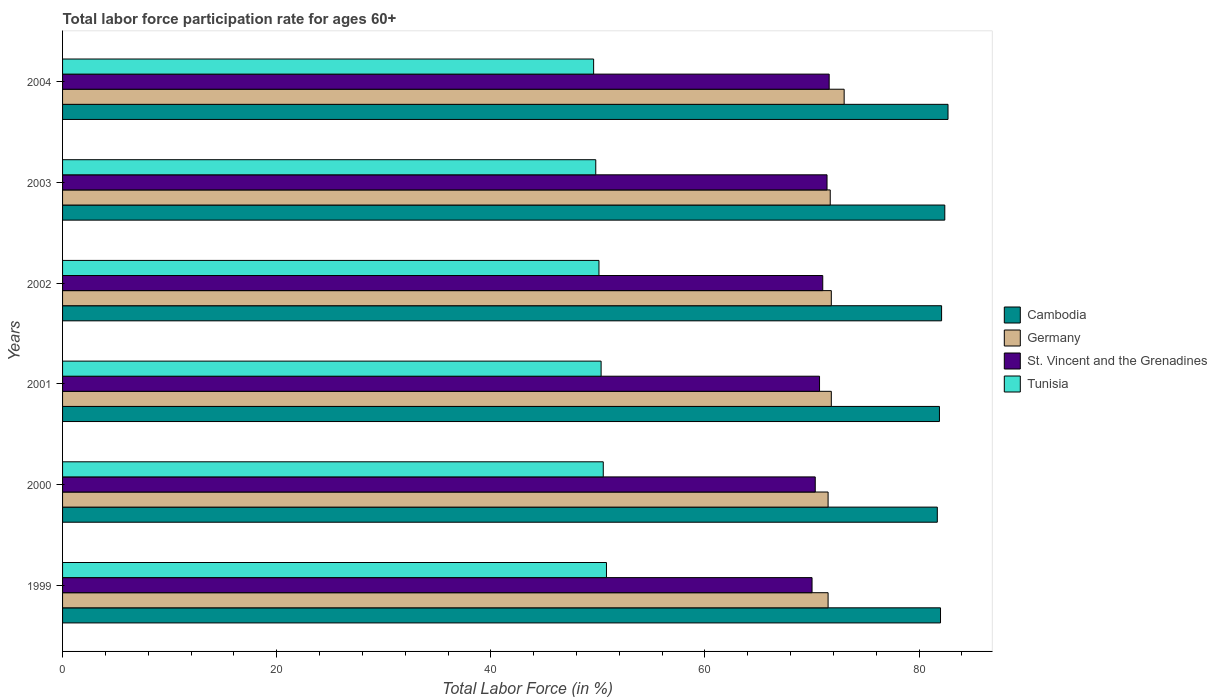How many different coloured bars are there?
Provide a short and direct response. 4. How many groups of bars are there?
Provide a succinct answer. 6. Are the number of bars on each tick of the Y-axis equal?
Ensure brevity in your answer.  Yes. How many bars are there on the 4th tick from the bottom?
Your answer should be very brief. 4. Across all years, what is the maximum labor force participation rate in Tunisia?
Your response must be concise. 50.8. Across all years, what is the minimum labor force participation rate in St. Vincent and the Grenadines?
Ensure brevity in your answer.  70. In which year was the labor force participation rate in Cambodia minimum?
Your response must be concise. 2000. What is the total labor force participation rate in Germany in the graph?
Your answer should be compact. 431.3. What is the difference between the labor force participation rate in Germany in 2002 and that in 2003?
Provide a succinct answer. 0.1. What is the difference between the labor force participation rate in Germany in 2004 and the labor force participation rate in Cambodia in 2003?
Keep it short and to the point. -9.4. What is the average labor force participation rate in Tunisia per year?
Keep it short and to the point. 50.18. In the year 1999, what is the difference between the labor force participation rate in Tunisia and labor force participation rate in Germany?
Offer a very short reply. -20.7. In how many years, is the labor force participation rate in Cambodia greater than 80 %?
Offer a very short reply. 6. What is the ratio of the labor force participation rate in Cambodia in 1999 to that in 2002?
Ensure brevity in your answer.  1. Is the labor force participation rate in Cambodia in 1999 less than that in 2002?
Offer a terse response. Yes. Is the difference between the labor force participation rate in Tunisia in 2000 and 2001 greater than the difference between the labor force participation rate in Germany in 2000 and 2001?
Provide a short and direct response. Yes. What is the difference between the highest and the second highest labor force participation rate in Germany?
Give a very brief answer. 1.2. What is the difference between the highest and the lowest labor force participation rate in Cambodia?
Your answer should be very brief. 1. Is the sum of the labor force participation rate in Tunisia in 2001 and 2002 greater than the maximum labor force participation rate in Cambodia across all years?
Your answer should be compact. Yes. Is it the case that in every year, the sum of the labor force participation rate in Cambodia and labor force participation rate in St. Vincent and the Grenadines is greater than the sum of labor force participation rate in Germany and labor force participation rate in Tunisia?
Provide a succinct answer. Yes. What does the 4th bar from the top in 2000 represents?
Offer a very short reply. Cambodia. What does the 2nd bar from the bottom in 1999 represents?
Your answer should be very brief. Germany. Is it the case that in every year, the sum of the labor force participation rate in Germany and labor force participation rate in Tunisia is greater than the labor force participation rate in St. Vincent and the Grenadines?
Provide a succinct answer. Yes. Does the graph contain any zero values?
Your answer should be very brief. No. Does the graph contain grids?
Give a very brief answer. No. How many legend labels are there?
Keep it short and to the point. 4. How are the legend labels stacked?
Give a very brief answer. Vertical. What is the title of the graph?
Offer a terse response. Total labor force participation rate for ages 60+. Does "United Arab Emirates" appear as one of the legend labels in the graph?
Ensure brevity in your answer.  No. What is the label or title of the X-axis?
Offer a terse response. Total Labor Force (in %). What is the label or title of the Y-axis?
Ensure brevity in your answer.  Years. What is the Total Labor Force (in %) in Cambodia in 1999?
Keep it short and to the point. 82. What is the Total Labor Force (in %) of Germany in 1999?
Offer a very short reply. 71.5. What is the Total Labor Force (in %) in St. Vincent and the Grenadines in 1999?
Your answer should be very brief. 70. What is the Total Labor Force (in %) of Tunisia in 1999?
Your answer should be very brief. 50.8. What is the Total Labor Force (in %) of Cambodia in 2000?
Provide a succinct answer. 81.7. What is the Total Labor Force (in %) in Germany in 2000?
Make the answer very short. 71.5. What is the Total Labor Force (in %) in St. Vincent and the Grenadines in 2000?
Offer a terse response. 70.3. What is the Total Labor Force (in %) of Tunisia in 2000?
Make the answer very short. 50.5. What is the Total Labor Force (in %) of Cambodia in 2001?
Make the answer very short. 81.9. What is the Total Labor Force (in %) of Germany in 2001?
Your answer should be very brief. 71.8. What is the Total Labor Force (in %) of St. Vincent and the Grenadines in 2001?
Your answer should be very brief. 70.7. What is the Total Labor Force (in %) of Tunisia in 2001?
Make the answer very short. 50.3. What is the Total Labor Force (in %) in Cambodia in 2002?
Provide a succinct answer. 82.1. What is the Total Labor Force (in %) of Germany in 2002?
Ensure brevity in your answer.  71.8. What is the Total Labor Force (in %) in St. Vincent and the Grenadines in 2002?
Your answer should be compact. 71. What is the Total Labor Force (in %) of Tunisia in 2002?
Ensure brevity in your answer.  50.1. What is the Total Labor Force (in %) of Cambodia in 2003?
Your answer should be very brief. 82.4. What is the Total Labor Force (in %) of Germany in 2003?
Your response must be concise. 71.7. What is the Total Labor Force (in %) in St. Vincent and the Grenadines in 2003?
Keep it short and to the point. 71.4. What is the Total Labor Force (in %) of Tunisia in 2003?
Ensure brevity in your answer.  49.8. What is the Total Labor Force (in %) of Cambodia in 2004?
Provide a succinct answer. 82.7. What is the Total Labor Force (in %) in Germany in 2004?
Your response must be concise. 73. What is the Total Labor Force (in %) of St. Vincent and the Grenadines in 2004?
Keep it short and to the point. 71.6. What is the Total Labor Force (in %) of Tunisia in 2004?
Provide a succinct answer. 49.6. Across all years, what is the maximum Total Labor Force (in %) in Cambodia?
Keep it short and to the point. 82.7. Across all years, what is the maximum Total Labor Force (in %) of St. Vincent and the Grenadines?
Ensure brevity in your answer.  71.6. Across all years, what is the maximum Total Labor Force (in %) of Tunisia?
Make the answer very short. 50.8. Across all years, what is the minimum Total Labor Force (in %) of Cambodia?
Your answer should be very brief. 81.7. Across all years, what is the minimum Total Labor Force (in %) of Germany?
Give a very brief answer. 71.5. Across all years, what is the minimum Total Labor Force (in %) in Tunisia?
Give a very brief answer. 49.6. What is the total Total Labor Force (in %) in Cambodia in the graph?
Offer a very short reply. 492.8. What is the total Total Labor Force (in %) in Germany in the graph?
Provide a succinct answer. 431.3. What is the total Total Labor Force (in %) in St. Vincent and the Grenadines in the graph?
Give a very brief answer. 425. What is the total Total Labor Force (in %) of Tunisia in the graph?
Keep it short and to the point. 301.1. What is the difference between the Total Labor Force (in %) of St. Vincent and the Grenadines in 1999 and that in 2000?
Offer a very short reply. -0.3. What is the difference between the Total Labor Force (in %) of Tunisia in 1999 and that in 2000?
Give a very brief answer. 0.3. What is the difference between the Total Labor Force (in %) in Cambodia in 1999 and that in 2001?
Offer a very short reply. 0.1. What is the difference between the Total Labor Force (in %) of St. Vincent and the Grenadines in 1999 and that in 2001?
Provide a succinct answer. -0.7. What is the difference between the Total Labor Force (in %) of Cambodia in 1999 and that in 2002?
Offer a very short reply. -0.1. What is the difference between the Total Labor Force (in %) of Germany in 1999 and that in 2002?
Your answer should be compact. -0.3. What is the difference between the Total Labor Force (in %) of Tunisia in 1999 and that in 2002?
Give a very brief answer. 0.7. What is the difference between the Total Labor Force (in %) in Cambodia in 1999 and that in 2003?
Your response must be concise. -0.4. What is the difference between the Total Labor Force (in %) of Germany in 1999 and that in 2003?
Your answer should be compact. -0.2. What is the difference between the Total Labor Force (in %) in St. Vincent and the Grenadines in 1999 and that in 2003?
Offer a very short reply. -1.4. What is the difference between the Total Labor Force (in %) of Cambodia in 1999 and that in 2004?
Make the answer very short. -0.7. What is the difference between the Total Labor Force (in %) in Germany in 1999 and that in 2004?
Your response must be concise. -1.5. What is the difference between the Total Labor Force (in %) in St. Vincent and the Grenadines in 2000 and that in 2001?
Offer a very short reply. -0.4. What is the difference between the Total Labor Force (in %) of Tunisia in 2000 and that in 2001?
Provide a short and direct response. 0.2. What is the difference between the Total Labor Force (in %) in Cambodia in 2000 and that in 2002?
Ensure brevity in your answer.  -0.4. What is the difference between the Total Labor Force (in %) of Germany in 2000 and that in 2002?
Keep it short and to the point. -0.3. What is the difference between the Total Labor Force (in %) of St. Vincent and the Grenadines in 2000 and that in 2002?
Your answer should be very brief. -0.7. What is the difference between the Total Labor Force (in %) in Cambodia in 2000 and that in 2003?
Provide a succinct answer. -0.7. What is the difference between the Total Labor Force (in %) of St. Vincent and the Grenadines in 2000 and that in 2003?
Offer a terse response. -1.1. What is the difference between the Total Labor Force (in %) of Cambodia in 2000 and that in 2004?
Keep it short and to the point. -1. What is the difference between the Total Labor Force (in %) in Tunisia in 2000 and that in 2004?
Make the answer very short. 0.9. What is the difference between the Total Labor Force (in %) in Cambodia in 2001 and that in 2002?
Offer a terse response. -0.2. What is the difference between the Total Labor Force (in %) in Tunisia in 2001 and that in 2002?
Ensure brevity in your answer.  0.2. What is the difference between the Total Labor Force (in %) of Cambodia in 2001 and that in 2003?
Your answer should be very brief. -0.5. What is the difference between the Total Labor Force (in %) of Tunisia in 2001 and that in 2003?
Provide a succinct answer. 0.5. What is the difference between the Total Labor Force (in %) of Germany in 2001 and that in 2004?
Provide a succinct answer. -1.2. What is the difference between the Total Labor Force (in %) in St. Vincent and the Grenadines in 2001 and that in 2004?
Offer a terse response. -0.9. What is the difference between the Total Labor Force (in %) in Tunisia in 2001 and that in 2004?
Ensure brevity in your answer.  0.7. What is the difference between the Total Labor Force (in %) of Cambodia in 2002 and that in 2003?
Ensure brevity in your answer.  -0.3. What is the difference between the Total Labor Force (in %) of Germany in 2002 and that in 2003?
Ensure brevity in your answer.  0.1. What is the difference between the Total Labor Force (in %) in St. Vincent and the Grenadines in 2002 and that in 2003?
Give a very brief answer. -0.4. What is the difference between the Total Labor Force (in %) of Cambodia in 2002 and that in 2004?
Offer a terse response. -0.6. What is the difference between the Total Labor Force (in %) of Germany in 2002 and that in 2004?
Your answer should be compact. -1.2. What is the difference between the Total Labor Force (in %) in St. Vincent and the Grenadines in 2003 and that in 2004?
Offer a terse response. -0.2. What is the difference between the Total Labor Force (in %) of Tunisia in 2003 and that in 2004?
Your answer should be compact. 0.2. What is the difference between the Total Labor Force (in %) in Cambodia in 1999 and the Total Labor Force (in %) in Germany in 2000?
Provide a succinct answer. 10.5. What is the difference between the Total Labor Force (in %) in Cambodia in 1999 and the Total Labor Force (in %) in St. Vincent and the Grenadines in 2000?
Provide a succinct answer. 11.7. What is the difference between the Total Labor Force (in %) in Cambodia in 1999 and the Total Labor Force (in %) in Tunisia in 2000?
Your response must be concise. 31.5. What is the difference between the Total Labor Force (in %) in Germany in 1999 and the Total Labor Force (in %) in St. Vincent and the Grenadines in 2000?
Offer a very short reply. 1.2. What is the difference between the Total Labor Force (in %) of St. Vincent and the Grenadines in 1999 and the Total Labor Force (in %) of Tunisia in 2000?
Your response must be concise. 19.5. What is the difference between the Total Labor Force (in %) in Cambodia in 1999 and the Total Labor Force (in %) in Germany in 2001?
Ensure brevity in your answer.  10.2. What is the difference between the Total Labor Force (in %) of Cambodia in 1999 and the Total Labor Force (in %) of St. Vincent and the Grenadines in 2001?
Provide a succinct answer. 11.3. What is the difference between the Total Labor Force (in %) in Cambodia in 1999 and the Total Labor Force (in %) in Tunisia in 2001?
Your answer should be very brief. 31.7. What is the difference between the Total Labor Force (in %) of Germany in 1999 and the Total Labor Force (in %) of St. Vincent and the Grenadines in 2001?
Your answer should be very brief. 0.8. What is the difference between the Total Labor Force (in %) in Germany in 1999 and the Total Labor Force (in %) in Tunisia in 2001?
Ensure brevity in your answer.  21.2. What is the difference between the Total Labor Force (in %) of Cambodia in 1999 and the Total Labor Force (in %) of Germany in 2002?
Your answer should be compact. 10.2. What is the difference between the Total Labor Force (in %) in Cambodia in 1999 and the Total Labor Force (in %) in Tunisia in 2002?
Offer a terse response. 31.9. What is the difference between the Total Labor Force (in %) in Germany in 1999 and the Total Labor Force (in %) in Tunisia in 2002?
Provide a short and direct response. 21.4. What is the difference between the Total Labor Force (in %) of St. Vincent and the Grenadines in 1999 and the Total Labor Force (in %) of Tunisia in 2002?
Offer a very short reply. 19.9. What is the difference between the Total Labor Force (in %) of Cambodia in 1999 and the Total Labor Force (in %) of St. Vincent and the Grenadines in 2003?
Ensure brevity in your answer.  10.6. What is the difference between the Total Labor Force (in %) of Cambodia in 1999 and the Total Labor Force (in %) of Tunisia in 2003?
Keep it short and to the point. 32.2. What is the difference between the Total Labor Force (in %) in Germany in 1999 and the Total Labor Force (in %) in St. Vincent and the Grenadines in 2003?
Make the answer very short. 0.1. What is the difference between the Total Labor Force (in %) of Germany in 1999 and the Total Labor Force (in %) of Tunisia in 2003?
Offer a terse response. 21.7. What is the difference between the Total Labor Force (in %) of St. Vincent and the Grenadines in 1999 and the Total Labor Force (in %) of Tunisia in 2003?
Provide a succinct answer. 20.2. What is the difference between the Total Labor Force (in %) in Cambodia in 1999 and the Total Labor Force (in %) in Germany in 2004?
Provide a succinct answer. 9. What is the difference between the Total Labor Force (in %) in Cambodia in 1999 and the Total Labor Force (in %) in Tunisia in 2004?
Ensure brevity in your answer.  32.4. What is the difference between the Total Labor Force (in %) of Germany in 1999 and the Total Labor Force (in %) of Tunisia in 2004?
Give a very brief answer. 21.9. What is the difference between the Total Labor Force (in %) in St. Vincent and the Grenadines in 1999 and the Total Labor Force (in %) in Tunisia in 2004?
Give a very brief answer. 20.4. What is the difference between the Total Labor Force (in %) in Cambodia in 2000 and the Total Labor Force (in %) in Germany in 2001?
Your answer should be compact. 9.9. What is the difference between the Total Labor Force (in %) in Cambodia in 2000 and the Total Labor Force (in %) in Tunisia in 2001?
Ensure brevity in your answer.  31.4. What is the difference between the Total Labor Force (in %) of Germany in 2000 and the Total Labor Force (in %) of Tunisia in 2001?
Give a very brief answer. 21.2. What is the difference between the Total Labor Force (in %) in St. Vincent and the Grenadines in 2000 and the Total Labor Force (in %) in Tunisia in 2001?
Offer a very short reply. 20. What is the difference between the Total Labor Force (in %) in Cambodia in 2000 and the Total Labor Force (in %) in St. Vincent and the Grenadines in 2002?
Make the answer very short. 10.7. What is the difference between the Total Labor Force (in %) in Cambodia in 2000 and the Total Labor Force (in %) in Tunisia in 2002?
Make the answer very short. 31.6. What is the difference between the Total Labor Force (in %) of Germany in 2000 and the Total Labor Force (in %) of Tunisia in 2002?
Make the answer very short. 21.4. What is the difference between the Total Labor Force (in %) in St. Vincent and the Grenadines in 2000 and the Total Labor Force (in %) in Tunisia in 2002?
Offer a terse response. 20.2. What is the difference between the Total Labor Force (in %) in Cambodia in 2000 and the Total Labor Force (in %) in Tunisia in 2003?
Offer a terse response. 31.9. What is the difference between the Total Labor Force (in %) in Germany in 2000 and the Total Labor Force (in %) in St. Vincent and the Grenadines in 2003?
Give a very brief answer. 0.1. What is the difference between the Total Labor Force (in %) of Germany in 2000 and the Total Labor Force (in %) of Tunisia in 2003?
Give a very brief answer. 21.7. What is the difference between the Total Labor Force (in %) of Cambodia in 2000 and the Total Labor Force (in %) of Germany in 2004?
Keep it short and to the point. 8.7. What is the difference between the Total Labor Force (in %) of Cambodia in 2000 and the Total Labor Force (in %) of Tunisia in 2004?
Ensure brevity in your answer.  32.1. What is the difference between the Total Labor Force (in %) of Germany in 2000 and the Total Labor Force (in %) of St. Vincent and the Grenadines in 2004?
Make the answer very short. -0.1. What is the difference between the Total Labor Force (in %) of Germany in 2000 and the Total Labor Force (in %) of Tunisia in 2004?
Your answer should be very brief. 21.9. What is the difference between the Total Labor Force (in %) of St. Vincent and the Grenadines in 2000 and the Total Labor Force (in %) of Tunisia in 2004?
Offer a terse response. 20.7. What is the difference between the Total Labor Force (in %) in Cambodia in 2001 and the Total Labor Force (in %) in Germany in 2002?
Make the answer very short. 10.1. What is the difference between the Total Labor Force (in %) in Cambodia in 2001 and the Total Labor Force (in %) in St. Vincent and the Grenadines in 2002?
Make the answer very short. 10.9. What is the difference between the Total Labor Force (in %) of Cambodia in 2001 and the Total Labor Force (in %) of Tunisia in 2002?
Make the answer very short. 31.8. What is the difference between the Total Labor Force (in %) of Germany in 2001 and the Total Labor Force (in %) of Tunisia in 2002?
Provide a short and direct response. 21.7. What is the difference between the Total Labor Force (in %) in St. Vincent and the Grenadines in 2001 and the Total Labor Force (in %) in Tunisia in 2002?
Ensure brevity in your answer.  20.6. What is the difference between the Total Labor Force (in %) in Cambodia in 2001 and the Total Labor Force (in %) in Germany in 2003?
Provide a short and direct response. 10.2. What is the difference between the Total Labor Force (in %) in Cambodia in 2001 and the Total Labor Force (in %) in St. Vincent and the Grenadines in 2003?
Provide a short and direct response. 10.5. What is the difference between the Total Labor Force (in %) in Cambodia in 2001 and the Total Labor Force (in %) in Tunisia in 2003?
Your answer should be very brief. 32.1. What is the difference between the Total Labor Force (in %) in Germany in 2001 and the Total Labor Force (in %) in St. Vincent and the Grenadines in 2003?
Your answer should be very brief. 0.4. What is the difference between the Total Labor Force (in %) of St. Vincent and the Grenadines in 2001 and the Total Labor Force (in %) of Tunisia in 2003?
Ensure brevity in your answer.  20.9. What is the difference between the Total Labor Force (in %) in Cambodia in 2001 and the Total Labor Force (in %) in Germany in 2004?
Offer a very short reply. 8.9. What is the difference between the Total Labor Force (in %) of Cambodia in 2001 and the Total Labor Force (in %) of St. Vincent and the Grenadines in 2004?
Provide a succinct answer. 10.3. What is the difference between the Total Labor Force (in %) in Cambodia in 2001 and the Total Labor Force (in %) in Tunisia in 2004?
Your answer should be very brief. 32.3. What is the difference between the Total Labor Force (in %) in Germany in 2001 and the Total Labor Force (in %) in Tunisia in 2004?
Offer a very short reply. 22.2. What is the difference between the Total Labor Force (in %) of St. Vincent and the Grenadines in 2001 and the Total Labor Force (in %) of Tunisia in 2004?
Give a very brief answer. 21.1. What is the difference between the Total Labor Force (in %) in Cambodia in 2002 and the Total Labor Force (in %) in Germany in 2003?
Your answer should be compact. 10.4. What is the difference between the Total Labor Force (in %) in Cambodia in 2002 and the Total Labor Force (in %) in Tunisia in 2003?
Provide a succinct answer. 32.3. What is the difference between the Total Labor Force (in %) in Germany in 2002 and the Total Labor Force (in %) in St. Vincent and the Grenadines in 2003?
Your answer should be compact. 0.4. What is the difference between the Total Labor Force (in %) of Germany in 2002 and the Total Labor Force (in %) of Tunisia in 2003?
Ensure brevity in your answer.  22. What is the difference between the Total Labor Force (in %) in St. Vincent and the Grenadines in 2002 and the Total Labor Force (in %) in Tunisia in 2003?
Your response must be concise. 21.2. What is the difference between the Total Labor Force (in %) in Cambodia in 2002 and the Total Labor Force (in %) in St. Vincent and the Grenadines in 2004?
Give a very brief answer. 10.5. What is the difference between the Total Labor Force (in %) in Cambodia in 2002 and the Total Labor Force (in %) in Tunisia in 2004?
Give a very brief answer. 32.5. What is the difference between the Total Labor Force (in %) in St. Vincent and the Grenadines in 2002 and the Total Labor Force (in %) in Tunisia in 2004?
Your answer should be compact. 21.4. What is the difference between the Total Labor Force (in %) in Cambodia in 2003 and the Total Labor Force (in %) in Germany in 2004?
Your answer should be very brief. 9.4. What is the difference between the Total Labor Force (in %) of Cambodia in 2003 and the Total Labor Force (in %) of Tunisia in 2004?
Provide a short and direct response. 32.8. What is the difference between the Total Labor Force (in %) in Germany in 2003 and the Total Labor Force (in %) in Tunisia in 2004?
Offer a terse response. 22.1. What is the difference between the Total Labor Force (in %) in St. Vincent and the Grenadines in 2003 and the Total Labor Force (in %) in Tunisia in 2004?
Your answer should be compact. 21.8. What is the average Total Labor Force (in %) in Cambodia per year?
Your answer should be very brief. 82.13. What is the average Total Labor Force (in %) of Germany per year?
Your answer should be very brief. 71.88. What is the average Total Labor Force (in %) of St. Vincent and the Grenadines per year?
Make the answer very short. 70.83. What is the average Total Labor Force (in %) in Tunisia per year?
Provide a short and direct response. 50.18. In the year 1999, what is the difference between the Total Labor Force (in %) of Cambodia and Total Labor Force (in %) of Germany?
Give a very brief answer. 10.5. In the year 1999, what is the difference between the Total Labor Force (in %) in Cambodia and Total Labor Force (in %) in St. Vincent and the Grenadines?
Your answer should be compact. 12. In the year 1999, what is the difference between the Total Labor Force (in %) of Cambodia and Total Labor Force (in %) of Tunisia?
Your response must be concise. 31.2. In the year 1999, what is the difference between the Total Labor Force (in %) in Germany and Total Labor Force (in %) in Tunisia?
Give a very brief answer. 20.7. In the year 1999, what is the difference between the Total Labor Force (in %) in St. Vincent and the Grenadines and Total Labor Force (in %) in Tunisia?
Keep it short and to the point. 19.2. In the year 2000, what is the difference between the Total Labor Force (in %) in Cambodia and Total Labor Force (in %) in Germany?
Provide a succinct answer. 10.2. In the year 2000, what is the difference between the Total Labor Force (in %) in Cambodia and Total Labor Force (in %) in St. Vincent and the Grenadines?
Ensure brevity in your answer.  11.4. In the year 2000, what is the difference between the Total Labor Force (in %) in Cambodia and Total Labor Force (in %) in Tunisia?
Give a very brief answer. 31.2. In the year 2000, what is the difference between the Total Labor Force (in %) in Germany and Total Labor Force (in %) in St. Vincent and the Grenadines?
Offer a very short reply. 1.2. In the year 2000, what is the difference between the Total Labor Force (in %) of Germany and Total Labor Force (in %) of Tunisia?
Your response must be concise. 21. In the year 2000, what is the difference between the Total Labor Force (in %) in St. Vincent and the Grenadines and Total Labor Force (in %) in Tunisia?
Your response must be concise. 19.8. In the year 2001, what is the difference between the Total Labor Force (in %) in Cambodia and Total Labor Force (in %) in Germany?
Your answer should be compact. 10.1. In the year 2001, what is the difference between the Total Labor Force (in %) in Cambodia and Total Labor Force (in %) in Tunisia?
Offer a terse response. 31.6. In the year 2001, what is the difference between the Total Labor Force (in %) of Germany and Total Labor Force (in %) of St. Vincent and the Grenadines?
Your answer should be very brief. 1.1. In the year 2001, what is the difference between the Total Labor Force (in %) of Germany and Total Labor Force (in %) of Tunisia?
Give a very brief answer. 21.5. In the year 2001, what is the difference between the Total Labor Force (in %) of St. Vincent and the Grenadines and Total Labor Force (in %) of Tunisia?
Make the answer very short. 20.4. In the year 2002, what is the difference between the Total Labor Force (in %) of Cambodia and Total Labor Force (in %) of Germany?
Ensure brevity in your answer.  10.3. In the year 2002, what is the difference between the Total Labor Force (in %) of Germany and Total Labor Force (in %) of St. Vincent and the Grenadines?
Offer a terse response. 0.8. In the year 2002, what is the difference between the Total Labor Force (in %) in Germany and Total Labor Force (in %) in Tunisia?
Provide a succinct answer. 21.7. In the year 2002, what is the difference between the Total Labor Force (in %) of St. Vincent and the Grenadines and Total Labor Force (in %) of Tunisia?
Provide a short and direct response. 20.9. In the year 2003, what is the difference between the Total Labor Force (in %) in Cambodia and Total Labor Force (in %) in Germany?
Keep it short and to the point. 10.7. In the year 2003, what is the difference between the Total Labor Force (in %) of Cambodia and Total Labor Force (in %) of St. Vincent and the Grenadines?
Your response must be concise. 11. In the year 2003, what is the difference between the Total Labor Force (in %) in Cambodia and Total Labor Force (in %) in Tunisia?
Make the answer very short. 32.6. In the year 2003, what is the difference between the Total Labor Force (in %) in Germany and Total Labor Force (in %) in Tunisia?
Offer a terse response. 21.9. In the year 2003, what is the difference between the Total Labor Force (in %) of St. Vincent and the Grenadines and Total Labor Force (in %) of Tunisia?
Offer a very short reply. 21.6. In the year 2004, what is the difference between the Total Labor Force (in %) in Cambodia and Total Labor Force (in %) in St. Vincent and the Grenadines?
Provide a succinct answer. 11.1. In the year 2004, what is the difference between the Total Labor Force (in %) of Cambodia and Total Labor Force (in %) of Tunisia?
Give a very brief answer. 33.1. In the year 2004, what is the difference between the Total Labor Force (in %) in Germany and Total Labor Force (in %) in Tunisia?
Your response must be concise. 23.4. What is the ratio of the Total Labor Force (in %) of Cambodia in 1999 to that in 2000?
Your answer should be compact. 1. What is the ratio of the Total Labor Force (in %) of Germany in 1999 to that in 2000?
Your response must be concise. 1. What is the ratio of the Total Labor Force (in %) of Tunisia in 1999 to that in 2000?
Offer a terse response. 1.01. What is the ratio of the Total Labor Force (in %) of Cambodia in 1999 to that in 2001?
Offer a very short reply. 1. What is the ratio of the Total Labor Force (in %) of St. Vincent and the Grenadines in 1999 to that in 2001?
Provide a succinct answer. 0.99. What is the ratio of the Total Labor Force (in %) of Tunisia in 1999 to that in 2001?
Your answer should be compact. 1.01. What is the ratio of the Total Labor Force (in %) of Cambodia in 1999 to that in 2002?
Provide a succinct answer. 1. What is the ratio of the Total Labor Force (in %) in Germany in 1999 to that in 2002?
Offer a terse response. 1. What is the ratio of the Total Labor Force (in %) of St. Vincent and the Grenadines in 1999 to that in 2002?
Keep it short and to the point. 0.99. What is the ratio of the Total Labor Force (in %) of Tunisia in 1999 to that in 2002?
Your answer should be compact. 1.01. What is the ratio of the Total Labor Force (in %) of Cambodia in 1999 to that in 2003?
Keep it short and to the point. 1. What is the ratio of the Total Labor Force (in %) in Germany in 1999 to that in 2003?
Offer a very short reply. 1. What is the ratio of the Total Labor Force (in %) of St. Vincent and the Grenadines in 1999 to that in 2003?
Make the answer very short. 0.98. What is the ratio of the Total Labor Force (in %) of Tunisia in 1999 to that in 2003?
Offer a terse response. 1.02. What is the ratio of the Total Labor Force (in %) of Cambodia in 1999 to that in 2004?
Ensure brevity in your answer.  0.99. What is the ratio of the Total Labor Force (in %) of Germany in 1999 to that in 2004?
Keep it short and to the point. 0.98. What is the ratio of the Total Labor Force (in %) of St. Vincent and the Grenadines in 1999 to that in 2004?
Your response must be concise. 0.98. What is the ratio of the Total Labor Force (in %) of Tunisia in 1999 to that in 2004?
Provide a succinct answer. 1.02. What is the ratio of the Total Labor Force (in %) of Germany in 2000 to that in 2001?
Give a very brief answer. 1. What is the ratio of the Total Labor Force (in %) of St. Vincent and the Grenadines in 2000 to that in 2001?
Provide a short and direct response. 0.99. What is the ratio of the Total Labor Force (in %) in St. Vincent and the Grenadines in 2000 to that in 2002?
Provide a short and direct response. 0.99. What is the ratio of the Total Labor Force (in %) of Cambodia in 2000 to that in 2003?
Give a very brief answer. 0.99. What is the ratio of the Total Labor Force (in %) in St. Vincent and the Grenadines in 2000 to that in 2003?
Your response must be concise. 0.98. What is the ratio of the Total Labor Force (in %) of Tunisia in 2000 to that in 2003?
Your response must be concise. 1.01. What is the ratio of the Total Labor Force (in %) of Cambodia in 2000 to that in 2004?
Your response must be concise. 0.99. What is the ratio of the Total Labor Force (in %) of Germany in 2000 to that in 2004?
Your response must be concise. 0.98. What is the ratio of the Total Labor Force (in %) of St. Vincent and the Grenadines in 2000 to that in 2004?
Offer a very short reply. 0.98. What is the ratio of the Total Labor Force (in %) of Tunisia in 2000 to that in 2004?
Your answer should be compact. 1.02. What is the ratio of the Total Labor Force (in %) in Cambodia in 2001 to that in 2002?
Provide a short and direct response. 1. What is the ratio of the Total Labor Force (in %) of Germany in 2001 to that in 2002?
Your response must be concise. 1. What is the ratio of the Total Labor Force (in %) in St. Vincent and the Grenadines in 2001 to that in 2002?
Keep it short and to the point. 1. What is the ratio of the Total Labor Force (in %) in Cambodia in 2001 to that in 2003?
Your answer should be very brief. 0.99. What is the ratio of the Total Labor Force (in %) of Germany in 2001 to that in 2003?
Give a very brief answer. 1. What is the ratio of the Total Labor Force (in %) of St. Vincent and the Grenadines in 2001 to that in 2003?
Ensure brevity in your answer.  0.99. What is the ratio of the Total Labor Force (in %) of Tunisia in 2001 to that in 2003?
Make the answer very short. 1.01. What is the ratio of the Total Labor Force (in %) in Cambodia in 2001 to that in 2004?
Provide a short and direct response. 0.99. What is the ratio of the Total Labor Force (in %) in Germany in 2001 to that in 2004?
Your response must be concise. 0.98. What is the ratio of the Total Labor Force (in %) of St. Vincent and the Grenadines in 2001 to that in 2004?
Offer a very short reply. 0.99. What is the ratio of the Total Labor Force (in %) in Tunisia in 2001 to that in 2004?
Your answer should be compact. 1.01. What is the ratio of the Total Labor Force (in %) of Cambodia in 2002 to that in 2003?
Make the answer very short. 1. What is the ratio of the Total Labor Force (in %) of St. Vincent and the Grenadines in 2002 to that in 2003?
Make the answer very short. 0.99. What is the ratio of the Total Labor Force (in %) of Cambodia in 2002 to that in 2004?
Offer a very short reply. 0.99. What is the ratio of the Total Labor Force (in %) in Germany in 2002 to that in 2004?
Your response must be concise. 0.98. What is the ratio of the Total Labor Force (in %) of St. Vincent and the Grenadines in 2002 to that in 2004?
Ensure brevity in your answer.  0.99. What is the ratio of the Total Labor Force (in %) of Germany in 2003 to that in 2004?
Offer a terse response. 0.98. What is the ratio of the Total Labor Force (in %) in Tunisia in 2003 to that in 2004?
Give a very brief answer. 1. What is the difference between the highest and the second highest Total Labor Force (in %) of Cambodia?
Provide a short and direct response. 0.3. What is the difference between the highest and the second highest Total Labor Force (in %) of Germany?
Ensure brevity in your answer.  1.2. What is the difference between the highest and the second highest Total Labor Force (in %) in St. Vincent and the Grenadines?
Offer a very short reply. 0.2. What is the difference between the highest and the second highest Total Labor Force (in %) of Tunisia?
Ensure brevity in your answer.  0.3. What is the difference between the highest and the lowest Total Labor Force (in %) in Cambodia?
Keep it short and to the point. 1. What is the difference between the highest and the lowest Total Labor Force (in %) in Germany?
Provide a short and direct response. 1.5. What is the difference between the highest and the lowest Total Labor Force (in %) in St. Vincent and the Grenadines?
Keep it short and to the point. 1.6. What is the difference between the highest and the lowest Total Labor Force (in %) of Tunisia?
Make the answer very short. 1.2. 